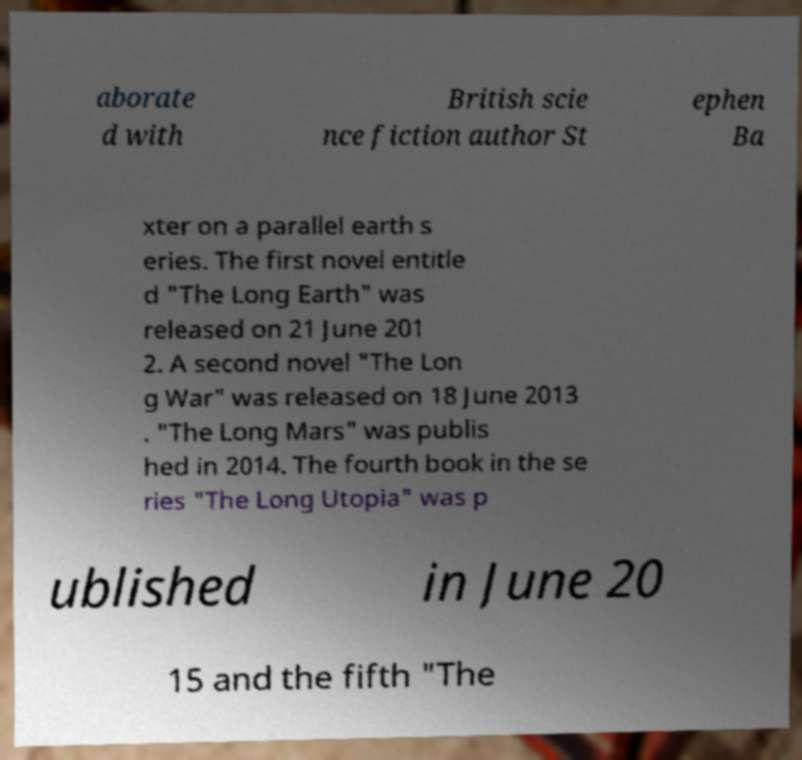Could you extract and type out the text from this image? aborate d with British scie nce fiction author St ephen Ba xter on a parallel earth s eries. The first novel entitle d "The Long Earth" was released on 21 June 201 2. A second novel "The Lon g War" was released on 18 June 2013 . "The Long Mars" was publis hed in 2014. The fourth book in the se ries "The Long Utopia" was p ublished in June 20 15 and the fifth "The 